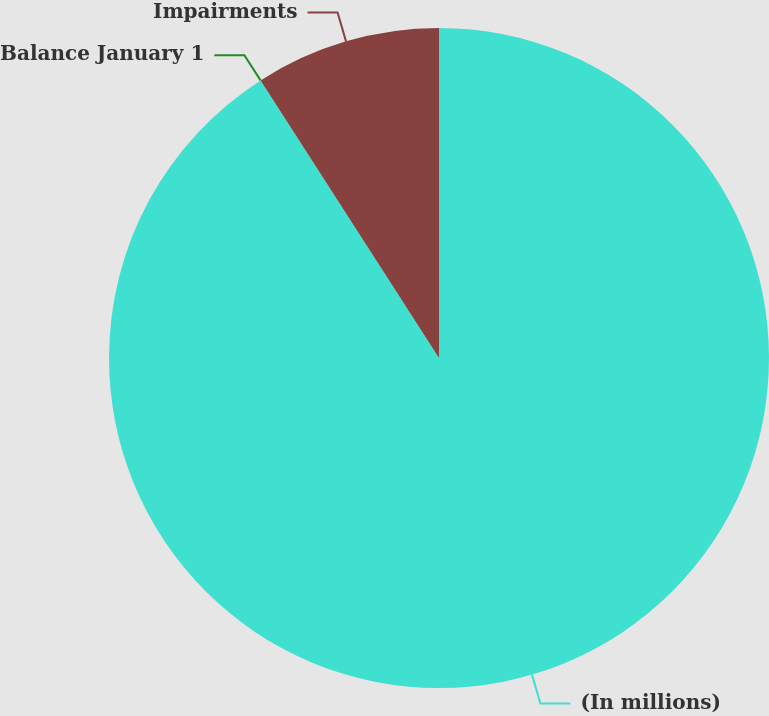Convert chart to OTSL. <chart><loc_0><loc_0><loc_500><loc_500><pie_chart><fcel>(In millions)<fcel>Balance January 1<fcel>Impairments<nl><fcel>90.9%<fcel>0.0%<fcel>9.09%<nl></chart> 